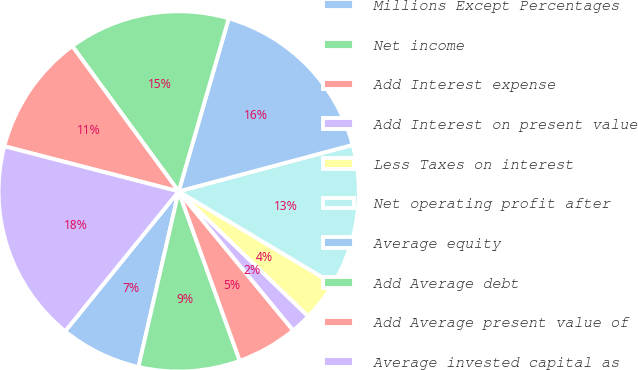<chart> <loc_0><loc_0><loc_500><loc_500><pie_chart><fcel>Millions Except Percentages<fcel>Net income<fcel>Add Interest expense<fcel>Add Interest on present value<fcel>Less Taxes on interest<fcel>Net operating profit after<fcel>Average equity<fcel>Add Average debt<fcel>Add Average present value of<fcel>Average invested capital as<nl><fcel>7.27%<fcel>9.09%<fcel>5.46%<fcel>1.82%<fcel>3.64%<fcel>12.73%<fcel>16.36%<fcel>14.54%<fcel>10.91%<fcel>18.18%<nl></chart> 